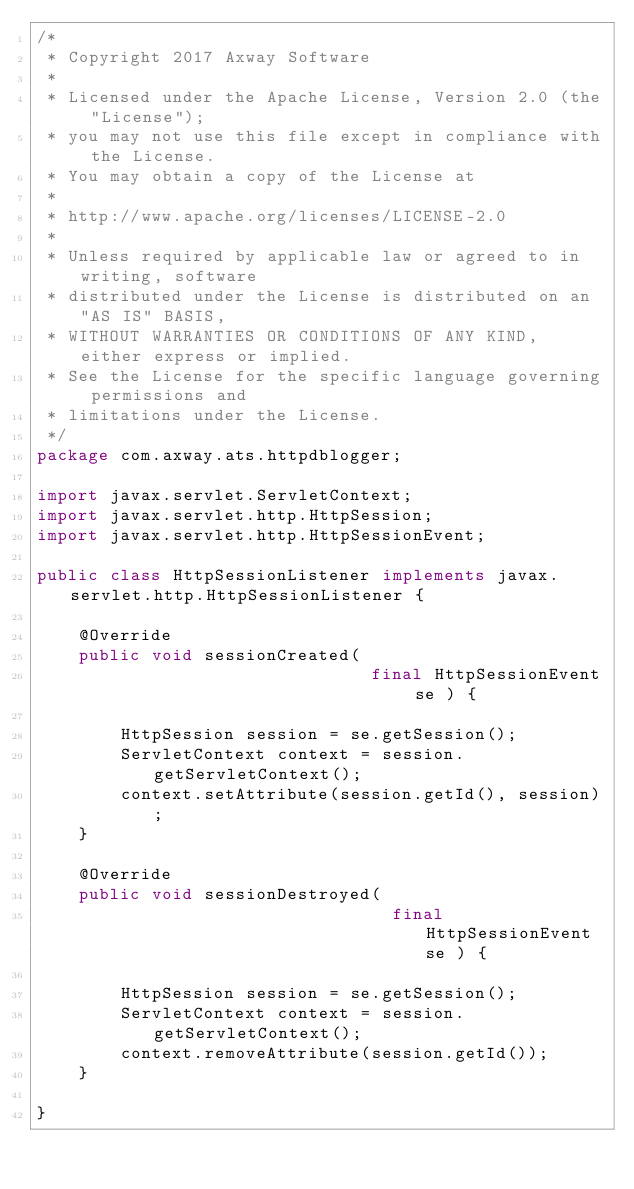<code> <loc_0><loc_0><loc_500><loc_500><_Java_>/*
 * Copyright 2017 Axway Software
 * 
 * Licensed under the Apache License, Version 2.0 (the "License");
 * you may not use this file except in compliance with the License.
 * You may obtain a copy of the License at
 * 
 * http://www.apache.org/licenses/LICENSE-2.0
 * 
 * Unless required by applicable law or agreed to in writing, software
 * distributed under the License is distributed on an "AS IS" BASIS,
 * WITHOUT WARRANTIES OR CONDITIONS OF ANY KIND, either express or implied.
 * See the License for the specific language governing permissions and
 * limitations under the License.
 */
package com.axway.ats.httpdblogger;

import javax.servlet.ServletContext;
import javax.servlet.http.HttpSession;
import javax.servlet.http.HttpSessionEvent;

public class HttpSessionListener implements javax.servlet.http.HttpSessionListener {

    @Override
    public void sessionCreated(
                                final HttpSessionEvent se ) {

        HttpSession session = se.getSession();
        ServletContext context = session.getServletContext();
        context.setAttribute(session.getId(), session);
    }

    @Override
    public void sessionDestroyed(
                                  final HttpSessionEvent se ) {

        HttpSession session = se.getSession();
        ServletContext context = session.getServletContext();
        context.removeAttribute(session.getId());
    }

}
</code> 